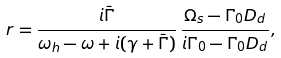<formula> <loc_0><loc_0><loc_500><loc_500>r = \frac { i \bar { \Gamma } } { \omega _ { h } - \omega + i ( \gamma + \bar { \Gamma } ) } \, \frac { \Omega _ { s } - \Gamma _ { 0 } D _ { d } } { i \Gamma _ { 0 } - \Gamma _ { 0 } D _ { d } } ,</formula> 